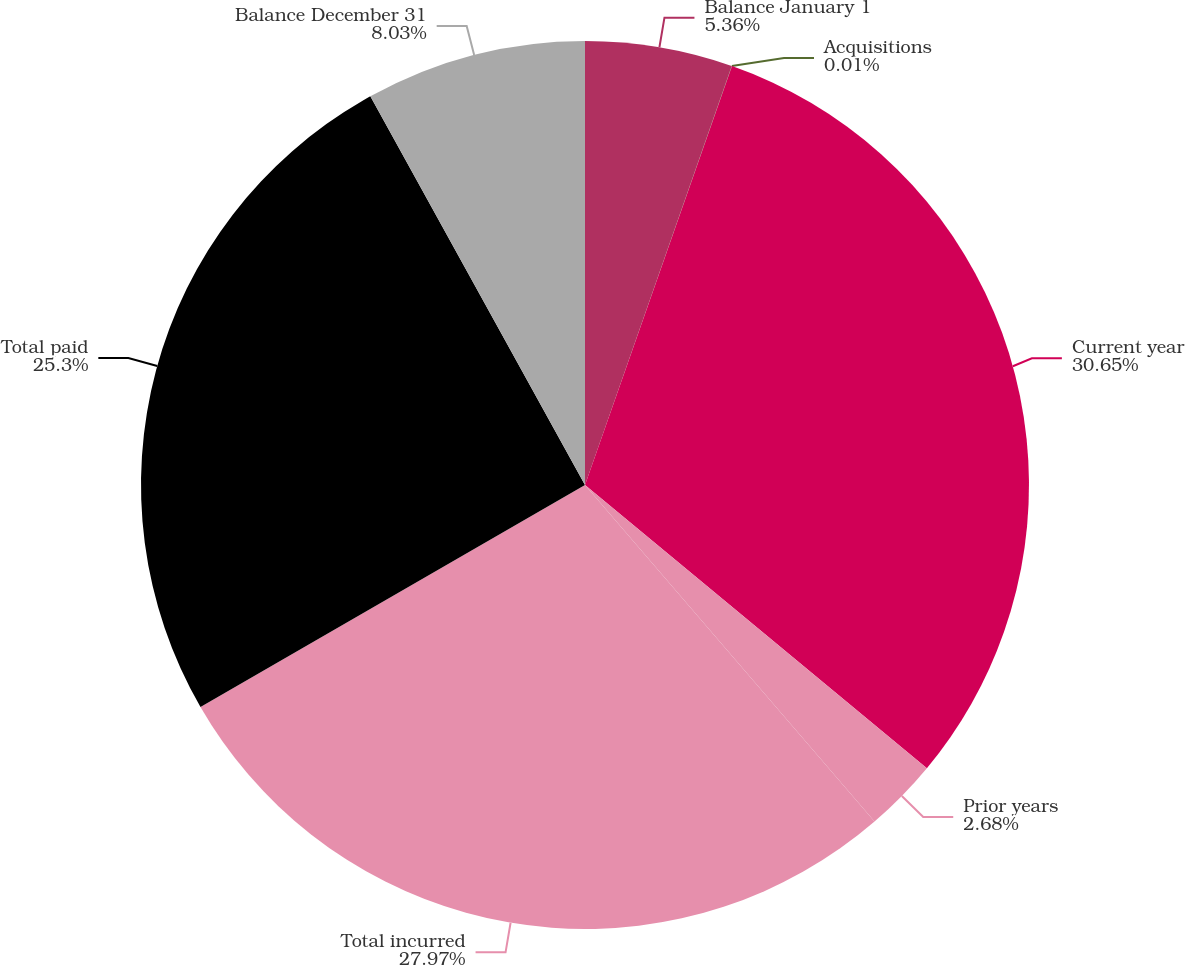Convert chart to OTSL. <chart><loc_0><loc_0><loc_500><loc_500><pie_chart><fcel>Balance January 1<fcel>Acquisitions<fcel>Current year<fcel>Prior years<fcel>Total incurred<fcel>Total paid<fcel>Balance December 31<nl><fcel>5.36%<fcel>0.01%<fcel>30.64%<fcel>2.68%<fcel>27.97%<fcel>25.3%<fcel>8.03%<nl></chart> 